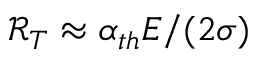Convert formula to latex. <formula><loc_0><loc_0><loc_500><loc_500>\ m a t h s c r { R } _ { T } \approx \alpha _ { t h } E / ( 2 \sigma )</formula> 